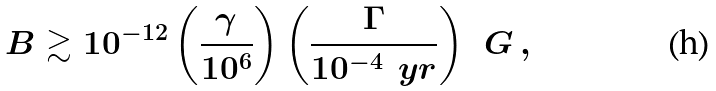Convert formula to latex. <formula><loc_0><loc_0><loc_500><loc_500>B \gtrsim 1 0 ^ { - 1 2 } \left ( \frac { \gamma } { 1 0 ^ { 6 } } \right ) \left ( \frac { \Gamma } { 1 0 ^ { - 4 } \, \ y r } \right ) \, \ G \, ,</formula> 